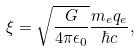<formula> <loc_0><loc_0><loc_500><loc_500>\xi = \sqrt { \frac { G } { 4 \pi \epsilon _ { 0 } } } \frac { m _ { e } q _ { e } } { \hbar { c } } ,</formula> 